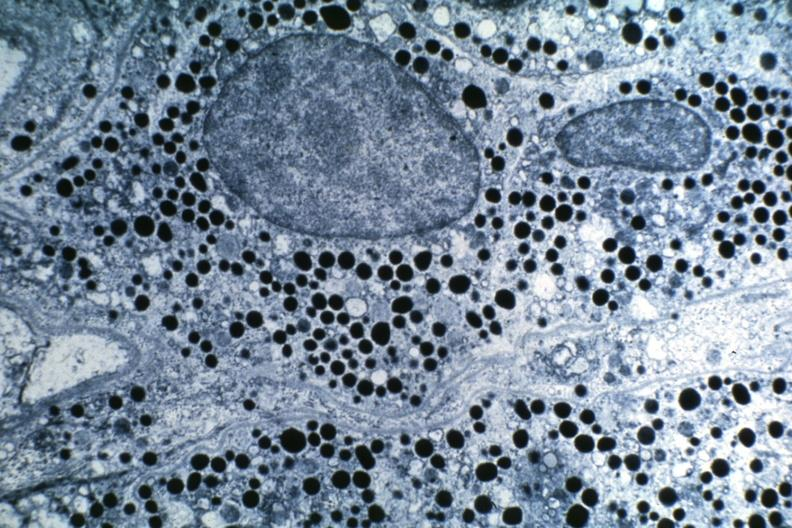does this image show prolactin secreting dr garcia tumors 34?
Answer the question using a single word or phrase. Yes 